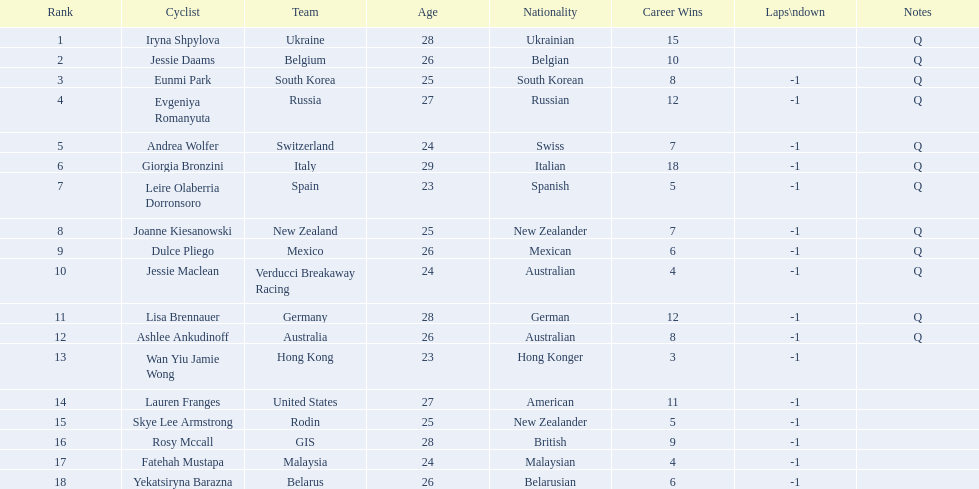Who was the competitor that finished above jessie maclean? Dulce Pliego. 